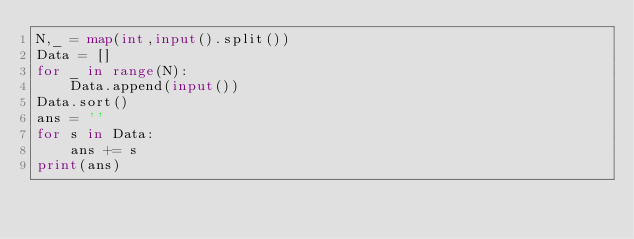Convert code to text. <code><loc_0><loc_0><loc_500><loc_500><_Python_>N,_ = map(int,input().split())
Data = []
for _ in range(N):
    Data.append(input())
Data.sort()
ans = ''
for s in Data:
    ans += s
print(ans)
</code> 